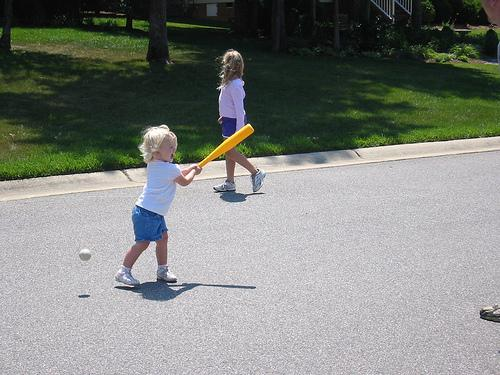Narrate the picture focusing on the two girls and their actions. In a suburban setting, a girl misses hitting a ball with a yellow bat, while another girl in the background faces away. Provide a succinct description of the primary event in the image. A child attempts to hit a white ball with a yellow plastic bat, in front of a sunny suburban backdrop. Briefly describe the main action and the environment in the picture. Children play baseball on a paved road with curbs, shadowed by beautiful green lawns and tall trees. Mention the primary focus of the image and the background elements. A child swinging a yellow bat at a white ball on the pavement, with a lush green yard, tree trunks, and a house with stairs in the background. Using descriptive language, depict the primary scene in the image. Amidst sunlit front yards and leafy tree trunks, a small girl brandishes a yellow plastic bat, poised to strike a white ball in mid-flight. Describe the scene involving the two girls in the image. A young girl is swinging a yellow bat at a white ball on the street, while another girl with wind-blown hair faces away from the camera. Summarize the key activity taking place in the image. A toddler girl is playing with a yellow plastic bat and a white ball in a paved street, while an older girl walks in the background. Describe the key elements and actions in the photo. A young girl swings a yellow plastic bat at a white ball on a paved road, shadows on the ground, and green grass and trees in the background. Focus on the main subject and their interaction in the picture. A young girl holds a yellow plastic bat, attempting to hit a white ball, while another girl turns away in the background. Detail the main event happening in the image and the surroundings. A toddler vigorously swings a yellow bat towards a white ball on a paved road, surrounded by green grass, tree shadows, and a house with front steps. Is there an old lady walking in the background of the picture? The instruction is misleading because there's an older girl walking, not an old lady. Can you find a little boy swinging a yellow plastic bat in the image? The instruction is misleading because there's a little girl swinging the bat, not a little boy. Identify the shadow of a bicycle in the image. This is misleading because there is no shadow of a bicycle; the shadows are of a ball, a girl, and trees. There is an orange basketball on the pavement. This is misleading because there's a white plastic ball instead of an orange basketball. Find the shadow of a cat on the ground. This is misleading because there's no shadow of a cat; there are shadows of a ball, a girl, and trees. Does the picture show a toddler girl wearing a red dress and a pastel-colored shirt? It is misleading because the toddler girl is wearing blue shorts and a pastel-colored shirt, not a red dress. Can you find a purple plastic ball in the image? It's misleading because the ball is white, not purple. Is there a young boy with wind blowing his hair visible in the image? The instruction is misleading because it's a young girl with wind blowing her hair, not a young boy. Look for a skateboard on the pavement. This is misleading because there's no skateboard on the pavement; there's a ball, a girl, and shadows. You may find a baseball bat made of wood lying on the ground in the photo. This is misleading because there's a yellow plastic bat and it's not lying on the ground; it's being swung by a girl. 